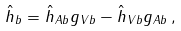<formula> <loc_0><loc_0><loc_500><loc_500>\hat { h } _ { b } = \hat { h } _ { A b } g _ { V b } - \hat { h } _ { V b } g _ { A b } \, ,</formula> 